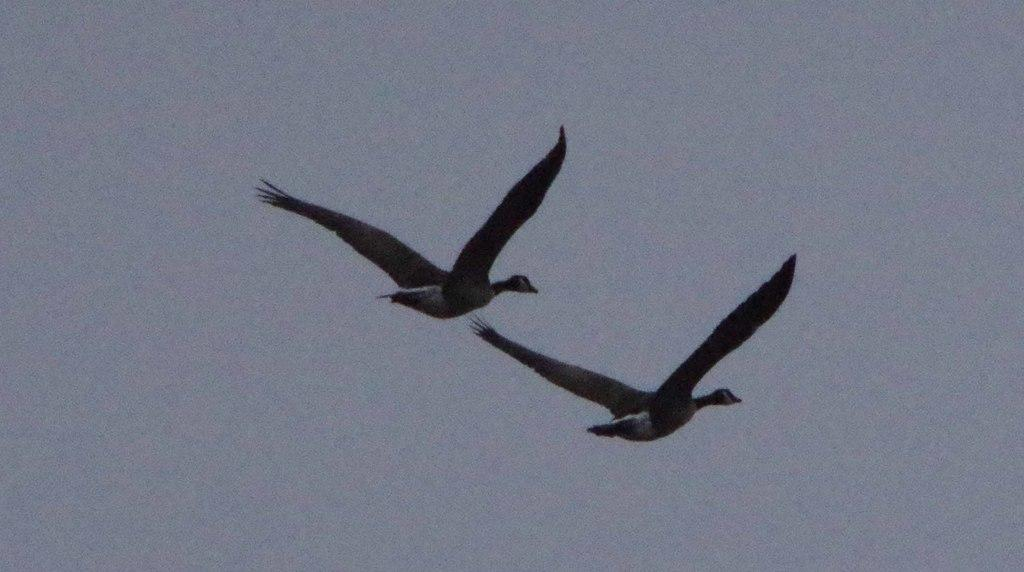What type of animals can be seen in the sky in the image? There are birds in the sky in the image. What language are the birds speaking in the image? Birds do not speak human languages, so it is not possible to determine what language they might be speaking in the image. 